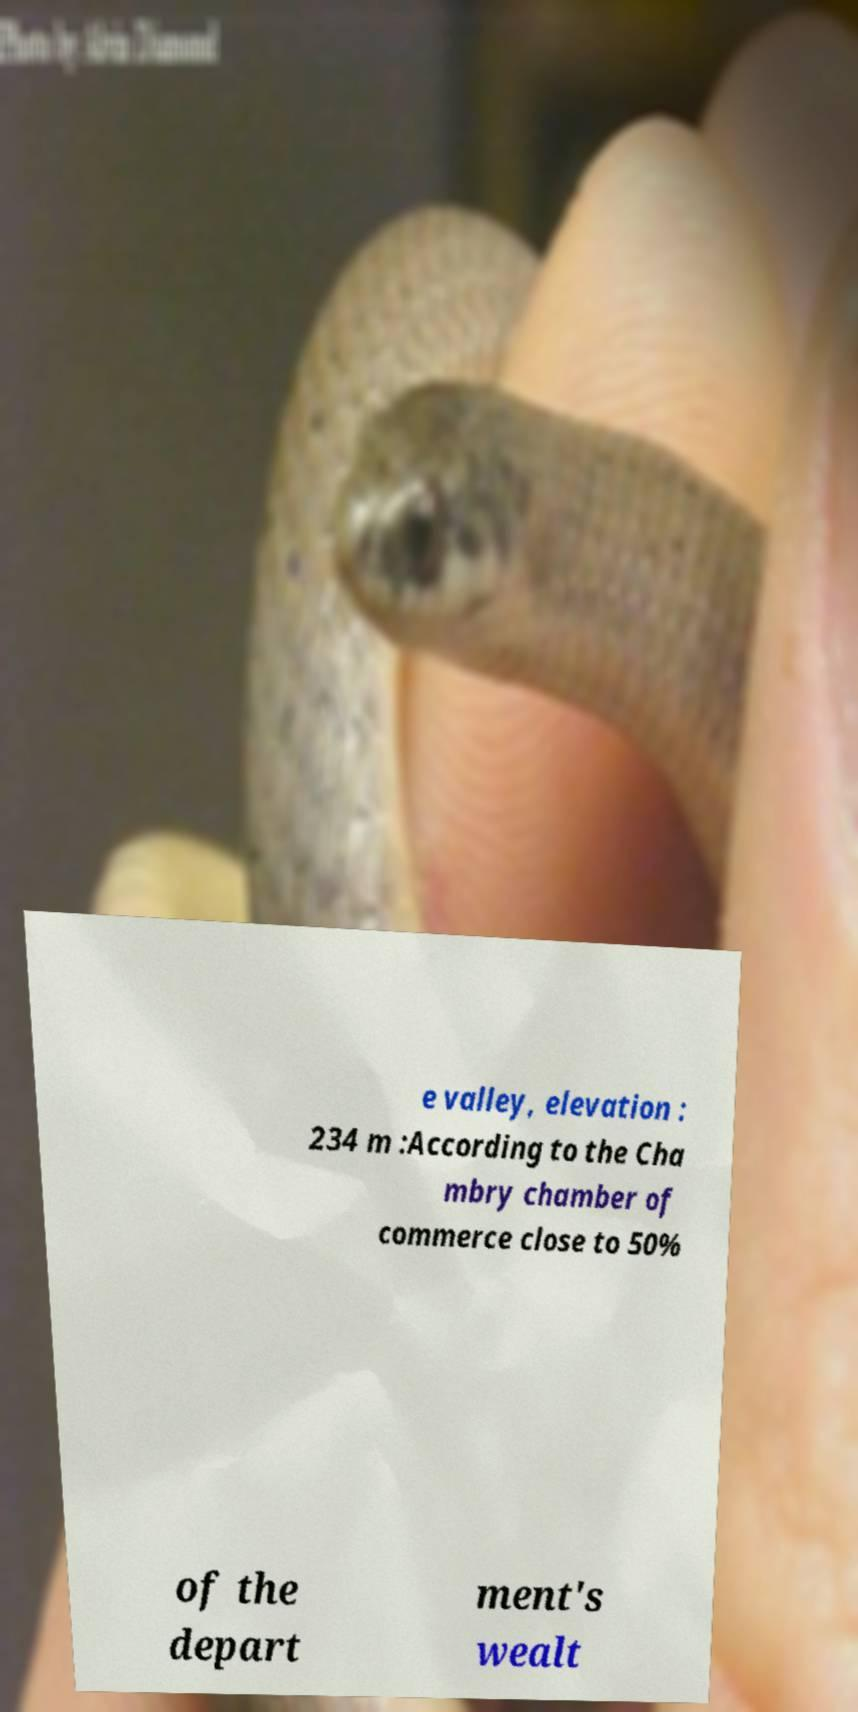Please read and relay the text visible in this image. What does it say? e valley, elevation : 234 m :According to the Cha mbry chamber of commerce close to 50% of the depart ment's wealt 